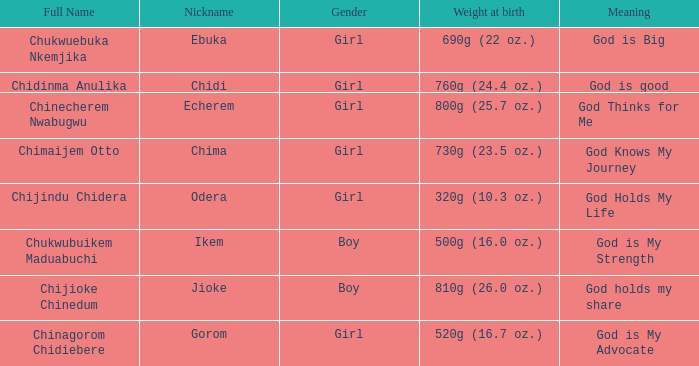What is the nickname of the baby with the birth weight of 730g (23.5 oz.)? Chima. 